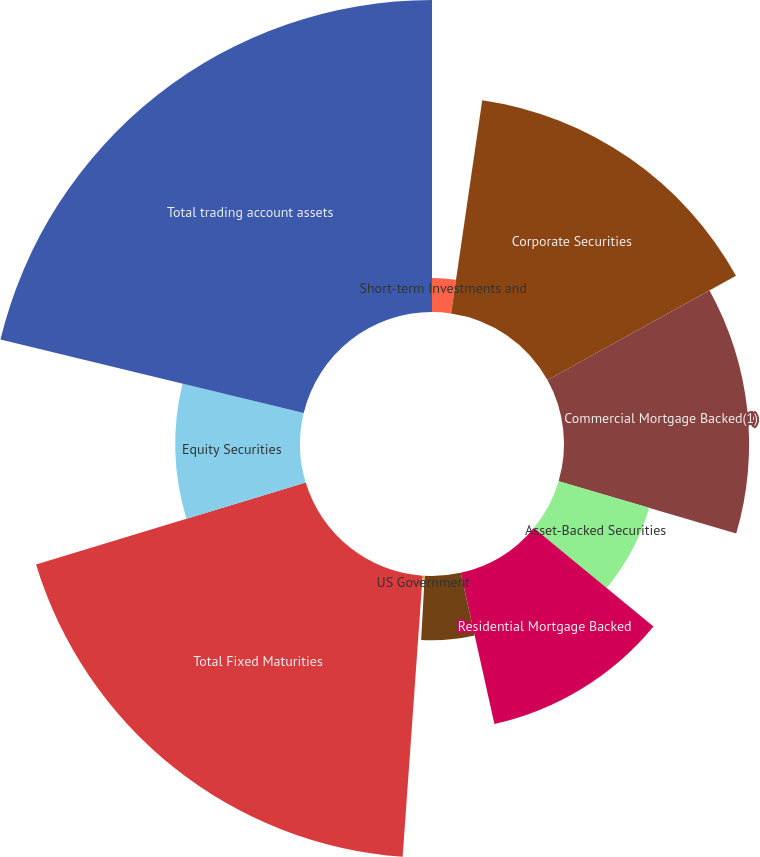Convert chart. <chart><loc_0><loc_0><loc_500><loc_500><pie_chart><fcel>Short-term Investments and<fcel>Corporate Securities<fcel>Commercial Mortgage Backed(1)<fcel>Asset-Backed Securities<fcel>Residential Mortgage Backed<fcel>Foreign Government<fcel>US Government<fcel>Total Fixed Maturities<fcel>Equity Securities<fcel>Total trading account assets<nl><fcel>2.31%<fcel>14.65%<fcel>12.59%<fcel>6.42%<fcel>10.54%<fcel>4.37%<fcel>0.25%<fcel>19.17%<fcel>8.48%<fcel>21.22%<nl></chart> 